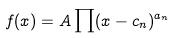<formula> <loc_0><loc_0><loc_500><loc_500>f ( x ) = A \prod ( x - c _ { n } ) ^ { a _ { n } }</formula> 